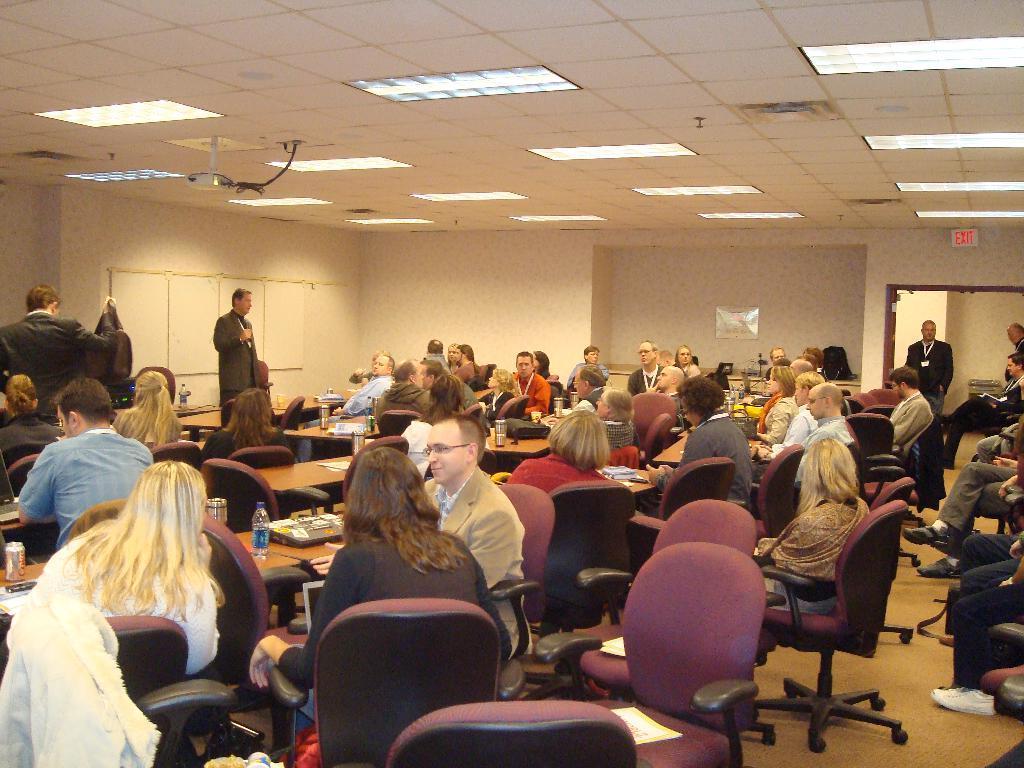Can you describe this image briefly? There are group of people sitting in a meeting room listening to a man's speech. 